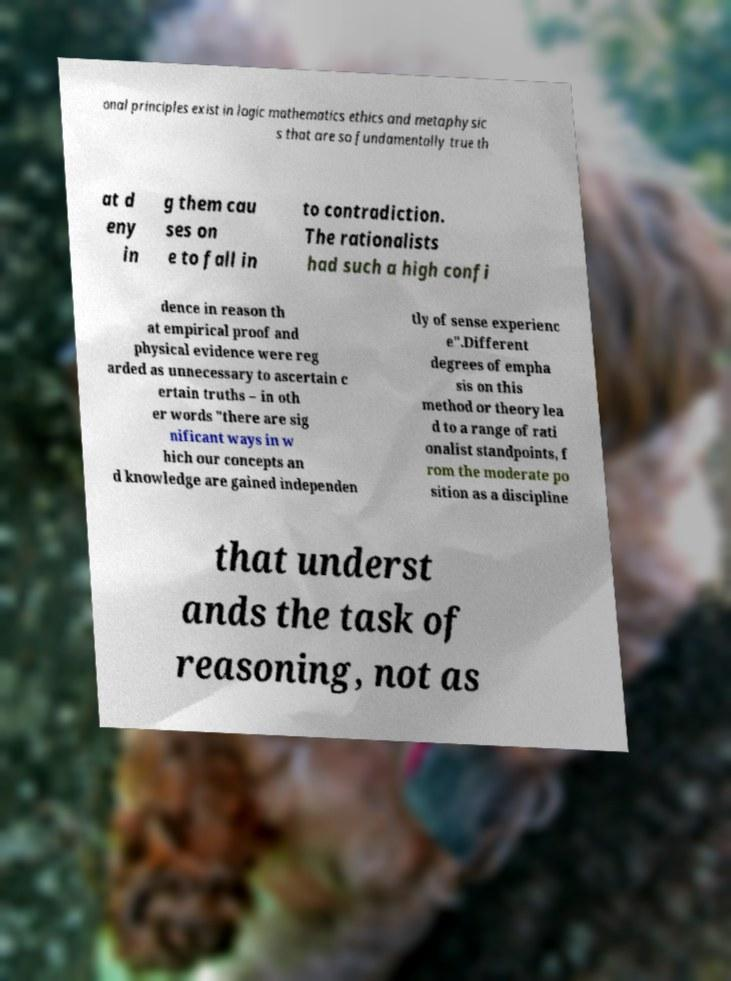Can you read and provide the text displayed in the image?This photo seems to have some interesting text. Can you extract and type it out for me? onal principles exist in logic mathematics ethics and metaphysic s that are so fundamentally true th at d eny in g them cau ses on e to fall in to contradiction. The rationalists had such a high confi dence in reason th at empirical proof and physical evidence were reg arded as unnecessary to ascertain c ertain truths – in oth er words "there are sig nificant ways in w hich our concepts an d knowledge are gained independen tly of sense experienc e".Different degrees of empha sis on this method or theory lea d to a range of rati onalist standpoints, f rom the moderate po sition as a discipline that underst ands the task of reasoning, not as 